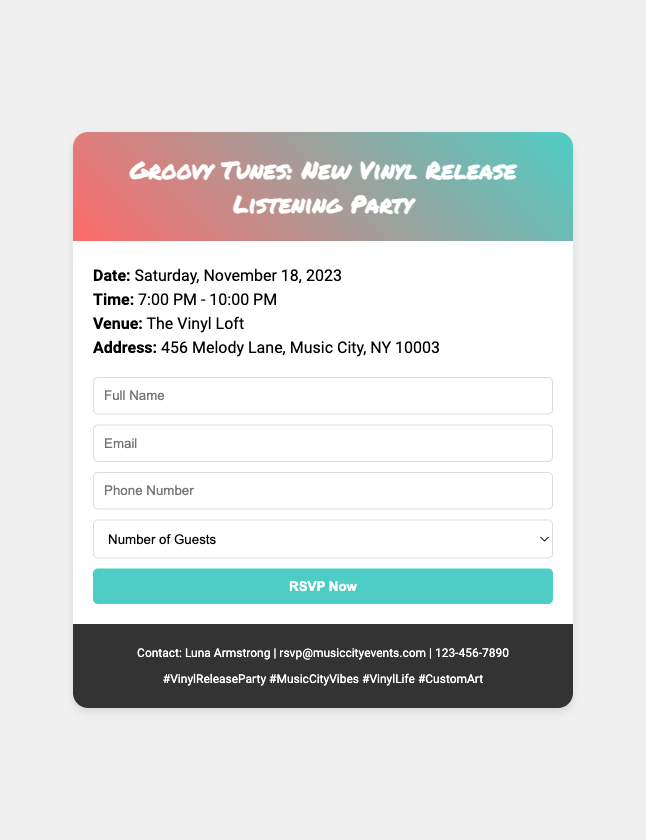What is the date of the event? The date of the event is listed in the document as Saturday, November 18, 2023.
Answer: Saturday, November 18, 2023 What time does the listening party start? The time of the event is specified in the document, which states it starts at 7:00 PM.
Answer: 7:00 PM Where is the event venue located? The document provides the venue's name and address, stating it is at The Vinyl Loft, 456 Melody Lane, Music City, NY 10003.
Answer: The Vinyl Loft Who should be contacted for RSVP? The contact person for the RSVP is mentioned at the bottom of the document, which is Luna Armstrong.
Answer: Luna Armstrong How many guests can you RSVP for? The document outlines a selection dropdown for guests, indicating options from 1 to 4 guests.
Answer: 1-4 guests What is the email address for RSVPs? The RSVP email address is provided in the document as rsvp@musiccityevents.com.
Answer: rsvp@musiccityevents.com What type of typography is used for the event title? The event title uses a specific font style mentioned in the document as 'Permanent Marker'.
Answer: Permanent Marker What is the primary color scheme of the RSVP card? The document describes the header's background as a gradient of red and teal colors.
Answer: Red and teal How can attendees RSVP to the event? The RSVP method is indicated through the form in the document, where attendees fill out their information and click the RSVP button.
Answer: RSVP form 